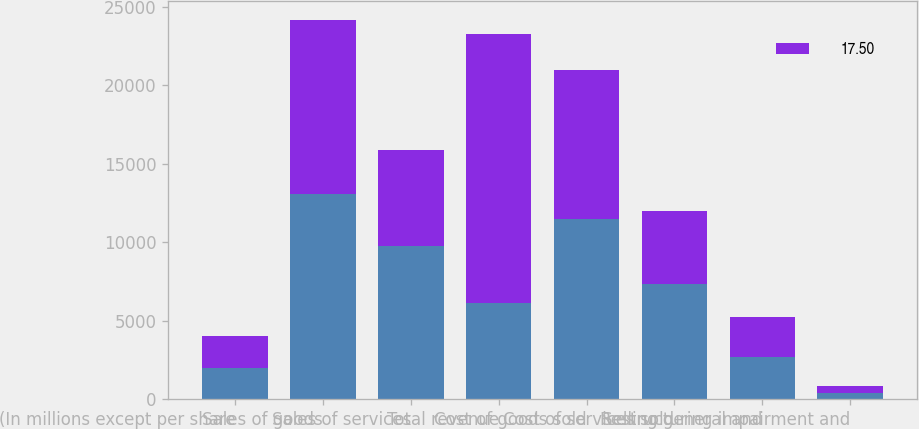<chart> <loc_0><loc_0><loc_500><loc_500><stacked_bar_chart><ecel><fcel>(In millions except per share<fcel>Sales of goods<fcel>Sales of services<fcel>Total revenue<fcel>Cost of goods sold<fcel>Cost of services sold<fcel>Selling general and<fcel>Restructuring impairment and<nl><fcel>nan<fcel>2018<fcel>13113<fcel>9764<fcel>6117<fcel>11524<fcel>7367<fcel>2699<fcel>433<nl><fcel>17.5<fcel>2017<fcel>11062<fcel>6117<fcel>17179<fcel>9486<fcel>4657<fcel>2535<fcel>412<nl></chart> 